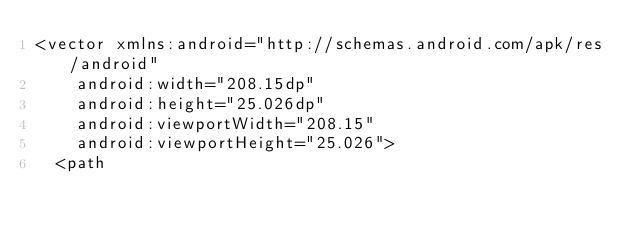Convert code to text. <code><loc_0><loc_0><loc_500><loc_500><_XML_><vector xmlns:android="http://schemas.android.com/apk/res/android"
    android:width="208.15dp"
    android:height="25.026dp"
    android:viewportWidth="208.15"
    android:viewportHeight="25.026">
  <path</code> 